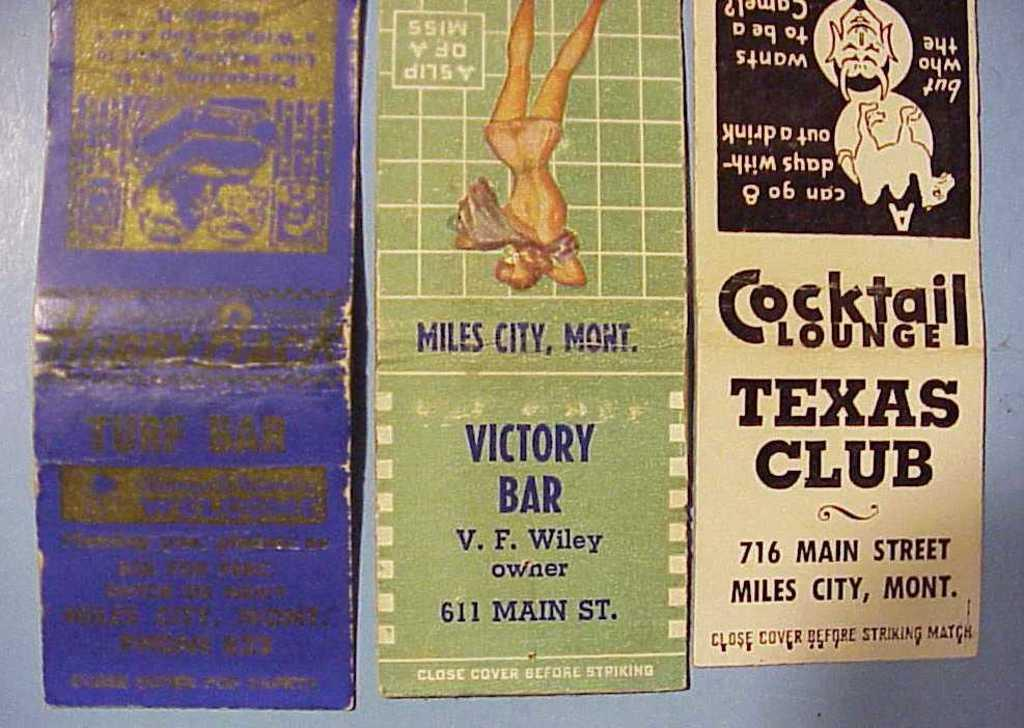<image>
Present a compact description of the photo's key features. A Texas Club Cocktail Lounge brochure sits next to a Victory Bar brochure 